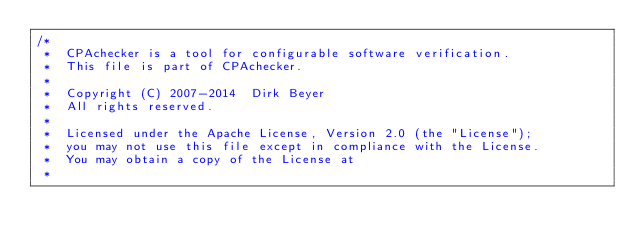<code> <loc_0><loc_0><loc_500><loc_500><_Java_>/*
 *  CPAchecker is a tool for configurable software verification.
 *  This file is part of CPAchecker.
 *
 *  Copyright (C) 2007-2014  Dirk Beyer
 *  All rights reserved.
 *
 *  Licensed under the Apache License, Version 2.0 (the "License");
 *  you may not use this file except in compliance with the License.
 *  You may obtain a copy of the License at
 *</code> 